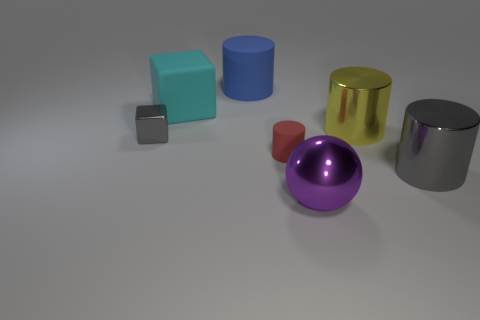How many other things are there of the same color as the metal cube?
Provide a short and direct response. 1. What number of cyan objects are either tiny cylinders or spheres?
Offer a terse response. 0. There is a matte cylinder that is in front of the gray thing on the left side of the gray cylinder; are there any cyan things behind it?
Your answer should be very brief. Yes. There is a object in front of the gray metal thing on the right side of the large blue matte thing; what is its color?
Your answer should be very brief. Purple. How many large things are either green metal balls or cylinders?
Provide a succinct answer. 3. What color is the large cylinder that is on the left side of the big gray thing and in front of the big cube?
Your answer should be compact. Yellow. Are the big sphere and the tiny gray block made of the same material?
Your answer should be very brief. Yes. What is the shape of the small rubber thing?
Make the answer very short. Cylinder. There is a matte cylinder that is behind the gray thing that is left of the big cyan cube; how many big yellow cylinders are behind it?
Offer a terse response. 0. There is a small rubber thing that is the same shape as the big blue rubber thing; what color is it?
Make the answer very short. Red. 